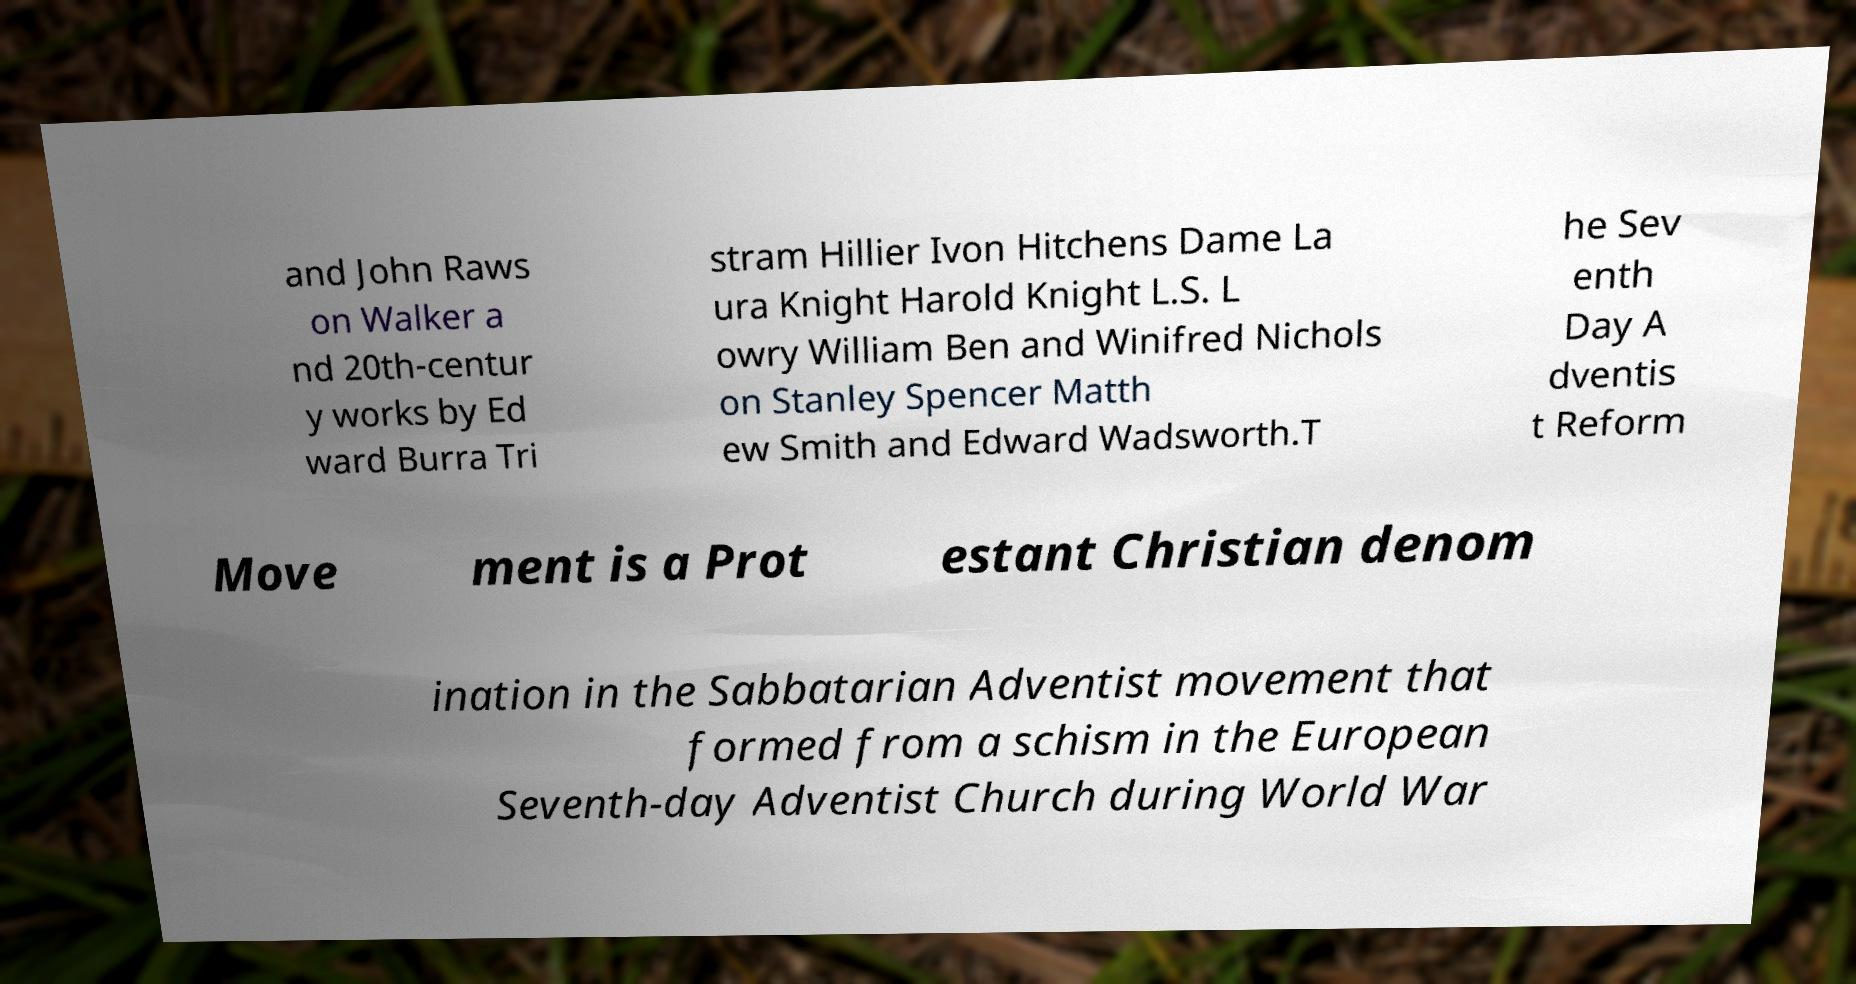Can you read and provide the text displayed in the image?This photo seems to have some interesting text. Can you extract and type it out for me? and John Raws on Walker a nd 20th-centur y works by Ed ward Burra Tri stram Hillier Ivon Hitchens Dame La ura Knight Harold Knight L.S. L owry William Ben and Winifred Nichols on Stanley Spencer Matth ew Smith and Edward Wadsworth.T he Sev enth Day A dventis t Reform Move ment is a Prot estant Christian denom ination in the Sabbatarian Adventist movement that formed from a schism in the European Seventh-day Adventist Church during World War 